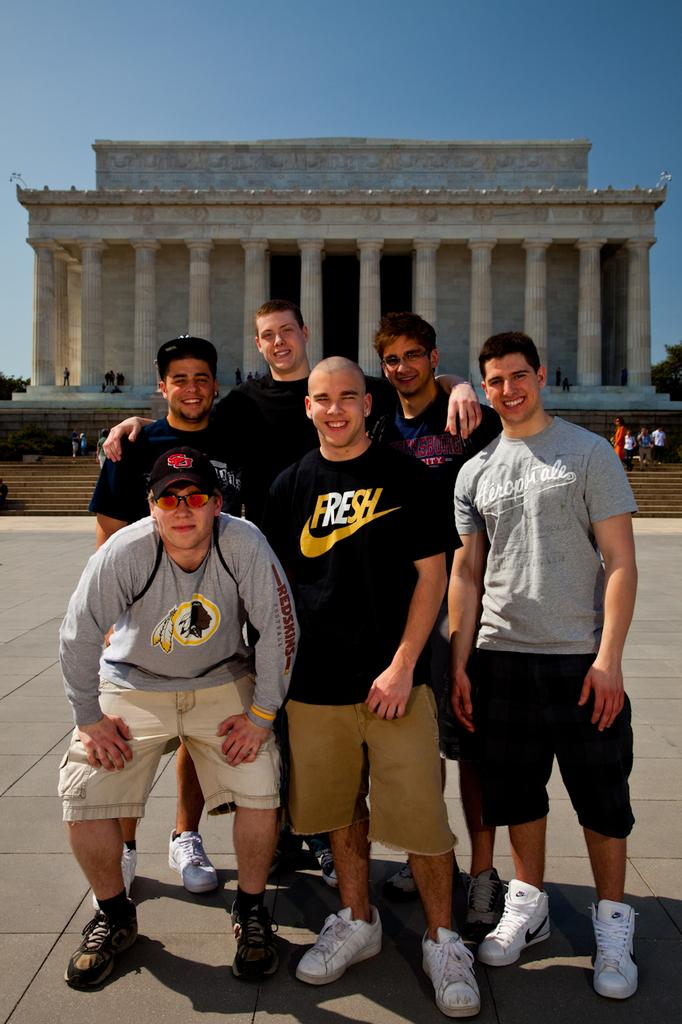Provide a one-sentence caption for the provided image. The men are standing in front of a monument and the one in the middle has a t-shirt that says fresh. 